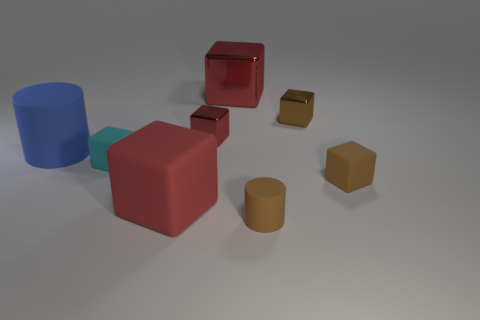How many objects are either large brown things or red objects behind the cyan matte block?
Your response must be concise. 2. There is a large object that is right of the large blue cylinder and to the left of the tiny red thing; what is its color?
Provide a short and direct response. Red. Is the size of the blue object the same as the cyan block?
Offer a very short reply. No. There is a large cube that is behind the blue cylinder; what is its color?
Give a very brief answer. Red. Are there any other metallic things of the same color as the big shiny object?
Ensure brevity in your answer.  Yes. There is a cylinder that is the same size as the cyan object; what is its color?
Provide a short and direct response. Brown. Does the big red metal thing have the same shape as the brown metallic object?
Your answer should be compact. Yes. What is the material of the small cube on the right side of the brown metallic thing?
Your answer should be compact. Rubber. What color is the large rubber cylinder?
Ensure brevity in your answer.  Blue. Is the size of the metallic block that is right of the tiny cylinder the same as the red metallic object that is right of the tiny red thing?
Give a very brief answer. No. 